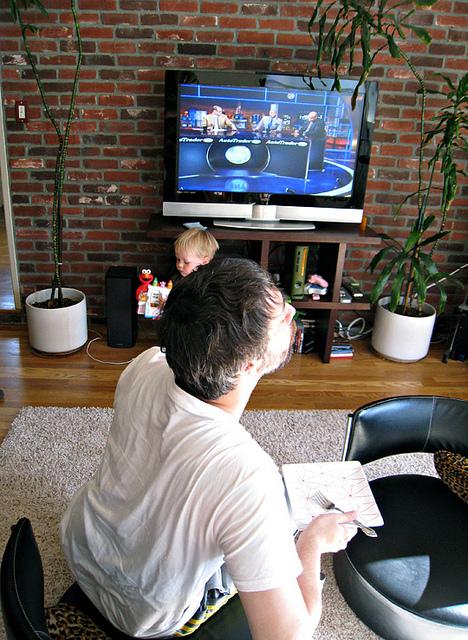What is baby doing?
Answer briefly. Playing. What is the man holding in his hands?
Give a very brief answer. Fork. Is the television on?
Keep it brief. Yes. 